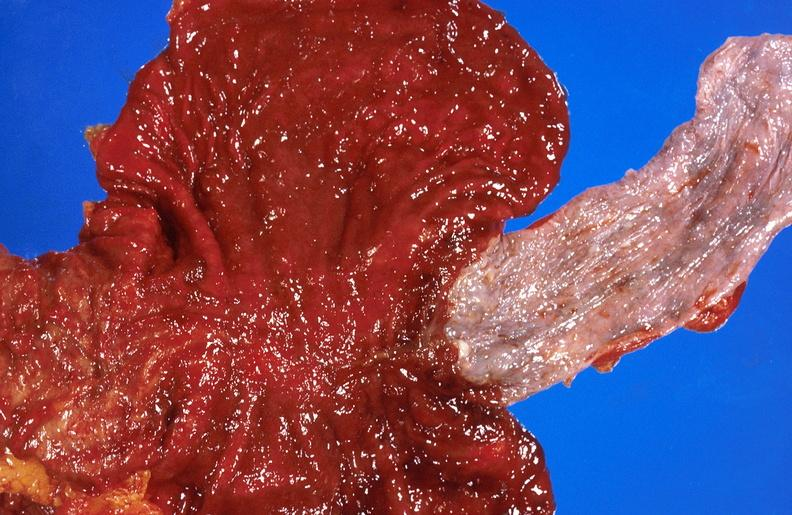s very good example present?
Answer the question using a single word or phrase. No 